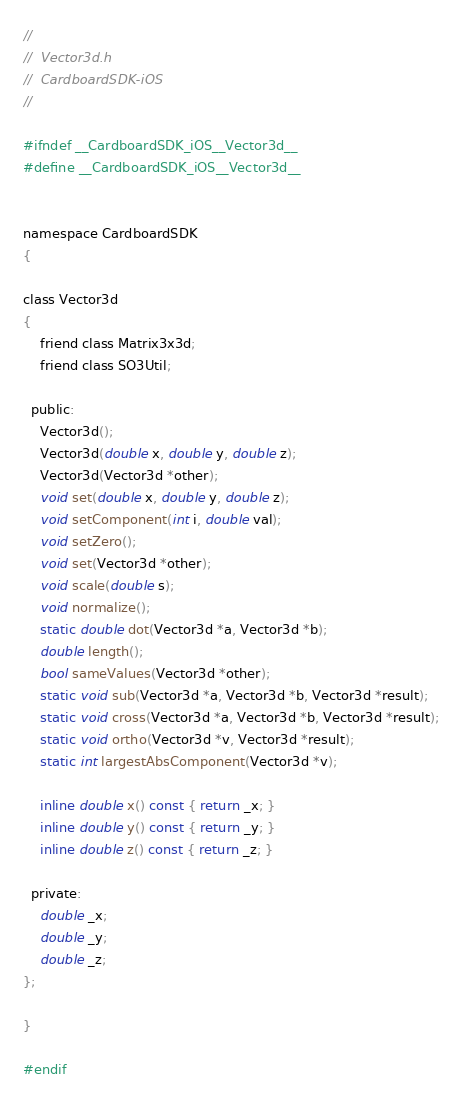Convert code to text. <code><loc_0><loc_0><loc_500><loc_500><_C_>//
//  Vector3d.h
//  CardboardSDK-iOS
//

#ifndef __CardboardSDK_iOS__Vector3d__
#define __CardboardSDK_iOS__Vector3d__


namespace CardboardSDK
{

class Vector3d
{
    friend class Matrix3x3d;
    friend class SO3Util;

  public:
    Vector3d();
    Vector3d(double x, double y, double z);
    Vector3d(Vector3d *other);
    void set(double x, double y, double z);
    void setComponent(int i, double val);
    void setZero();
    void set(Vector3d *other);
    void scale(double s);
    void normalize();
    static double dot(Vector3d *a, Vector3d *b);
    double length();
    bool sameValues(Vector3d *other);
    static void sub(Vector3d *a, Vector3d *b, Vector3d *result);
    static void cross(Vector3d *a, Vector3d *b, Vector3d *result);
    static void ortho(Vector3d *v, Vector3d *result);
    static int largestAbsComponent(Vector3d *v);
    
    inline double x() const { return _x; }
    inline double y() const { return _y; }
    inline double z() const { return _z; }

  private:
    double _x;
    double _y;
    double _z;
};

}

#endif</code> 